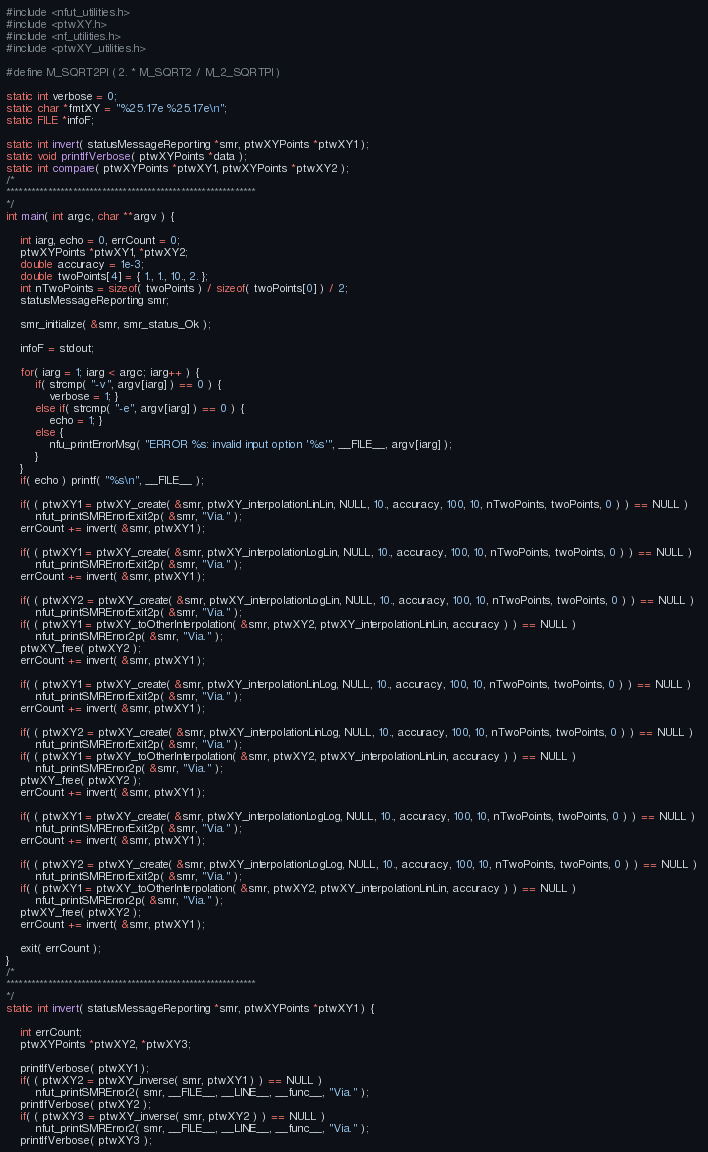<code> <loc_0><loc_0><loc_500><loc_500><_C_>#include <nfut_utilities.h>
#include <ptwXY.h>
#include <nf_utilities.h>
#include <ptwXY_utilities.h>

#define M_SQRT2PI ( 2. * M_SQRT2 / M_2_SQRTPI )

static int verbose = 0;
static char *fmtXY = "%25.17e %25.17e\n";
static FILE *infoF;

static int invert( statusMessageReporting *smr, ptwXYPoints *ptwXY1 );
static void printIfVerbose( ptwXYPoints *data );
static int compare( ptwXYPoints *ptwXY1, ptwXYPoints *ptwXY2 );
/*
************************************************************
*/
int main( int argc, char **argv ) {

    int iarg, echo = 0, errCount = 0;
    ptwXYPoints *ptwXY1, *ptwXY2;
    double accuracy = 1e-3;
    double twoPoints[4] = { 1., 1., 10., 2. };
    int nTwoPoints = sizeof( twoPoints ) / sizeof( twoPoints[0] ) / 2;
    statusMessageReporting smr;

    smr_initialize( &smr, smr_status_Ok );

    infoF = stdout;

    for( iarg = 1; iarg < argc; iarg++ ) {
        if( strcmp( "-v", argv[iarg] ) == 0 ) {
            verbose = 1; }
        else if( strcmp( "-e", argv[iarg] ) == 0 ) {
            echo = 1; }
        else {
            nfu_printErrorMsg( "ERROR %s: invalid input option '%s'", __FILE__, argv[iarg] );
        }
    }
    if( echo ) printf( "%s\n", __FILE__ );

    if( ( ptwXY1 = ptwXY_create( &smr, ptwXY_interpolationLinLin, NULL, 10., accuracy, 100, 10, nTwoPoints, twoPoints, 0 ) ) == NULL ) 
        nfut_printSMRErrorExit2p( &smr, "Via." );
    errCount += invert( &smr, ptwXY1 );

    if( ( ptwXY1 = ptwXY_create( &smr, ptwXY_interpolationLogLin, NULL, 10., accuracy, 100, 10, nTwoPoints, twoPoints, 0 ) ) == NULL ) 
        nfut_printSMRErrorExit2p( &smr, "Via." );
    errCount += invert( &smr, ptwXY1 );

    if( ( ptwXY2 = ptwXY_create( &smr, ptwXY_interpolationLogLin, NULL, 10., accuracy, 100, 10, nTwoPoints, twoPoints, 0 ) ) == NULL ) 
        nfut_printSMRErrorExit2p( &smr, "Via." );
    if( ( ptwXY1 = ptwXY_toOtherInterpolation( &smr, ptwXY2, ptwXY_interpolationLinLin, accuracy ) ) == NULL )
        nfut_printSMRError2p( &smr, "Via." );
    ptwXY_free( ptwXY2 );
    errCount += invert( &smr, ptwXY1 );

    if( ( ptwXY1 = ptwXY_create( &smr, ptwXY_interpolationLinLog, NULL, 10., accuracy, 100, 10, nTwoPoints, twoPoints, 0 ) ) == NULL ) 
        nfut_printSMRErrorExit2p( &smr, "Via." );
    errCount += invert( &smr, ptwXY1 );

    if( ( ptwXY2 = ptwXY_create( &smr, ptwXY_interpolationLinLog, NULL, 10., accuracy, 100, 10, nTwoPoints, twoPoints, 0 ) ) == NULL ) 
        nfut_printSMRErrorExit2p( &smr, "Via." );
    if( ( ptwXY1 = ptwXY_toOtherInterpolation( &smr, ptwXY2, ptwXY_interpolationLinLin, accuracy ) ) == NULL )
        nfut_printSMRError2p( &smr, "Via." );
    ptwXY_free( ptwXY2 );
    errCount += invert( &smr, ptwXY1 );

    if( ( ptwXY1 = ptwXY_create( &smr, ptwXY_interpolationLogLog, NULL, 10., accuracy, 100, 10, nTwoPoints, twoPoints, 0 ) ) == NULL ) 
        nfut_printSMRErrorExit2p( &smr, "Via." );
    errCount += invert( &smr, ptwXY1 );

    if( ( ptwXY2 = ptwXY_create( &smr, ptwXY_interpolationLogLog, NULL, 10., accuracy, 100, 10, nTwoPoints, twoPoints, 0 ) ) == NULL ) 
        nfut_printSMRErrorExit2p( &smr, "Via." );
    if( ( ptwXY1 = ptwXY_toOtherInterpolation( &smr, ptwXY2, ptwXY_interpolationLinLin, accuracy ) ) == NULL )
        nfut_printSMRError2p( &smr, "Via." );
    ptwXY_free( ptwXY2 );
    errCount += invert( &smr, ptwXY1 );

    exit( errCount );
}
/*
************************************************************
*/
static int invert( statusMessageReporting *smr, ptwXYPoints *ptwXY1 ) {

    int errCount;
    ptwXYPoints *ptwXY2, *ptwXY3;

    printIfVerbose( ptwXY1 );
    if( ( ptwXY2 = ptwXY_inverse( smr, ptwXY1 ) ) == NULL ) 
        nfut_printSMRError2( smr, __FILE__, __LINE__, __func__, "Via." );
    printIfVerbose( ptwXY2 );
    if( ( ptwXY3 = ptwXY_inverse( smr, ptwXY2 ) ) == NULL ) 
        nfut_printSMRError2( smr, __FILE__, __LINE__, __func__, "Via." );
    printIfVerbose( ptwXY3 );</code> 